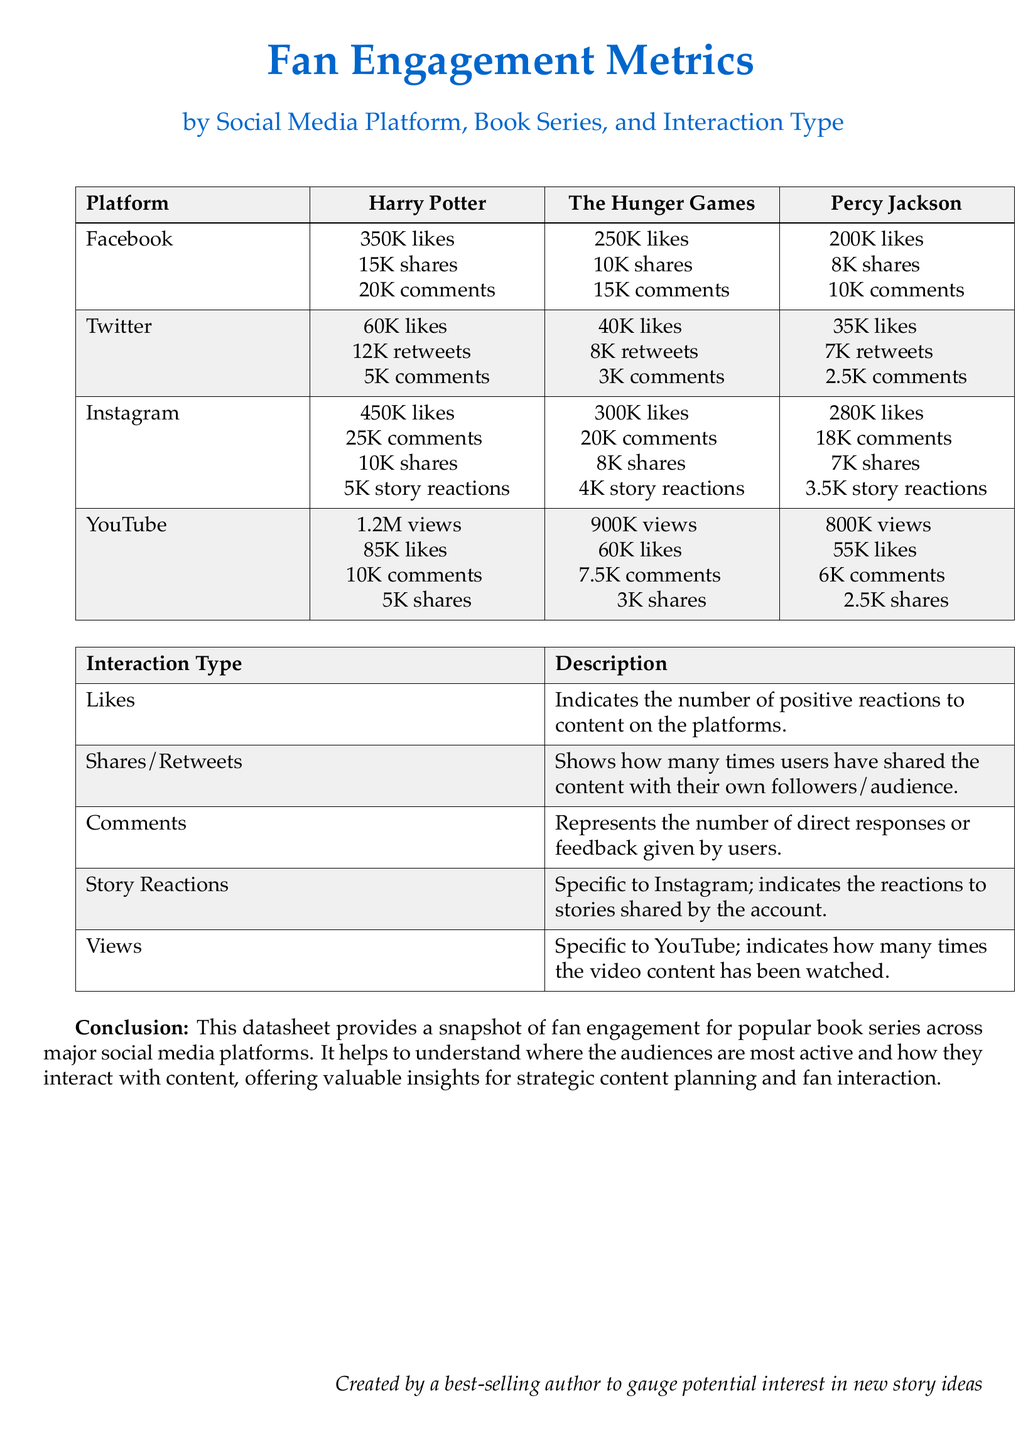What is the number of likes for Harry Potter on Facebook? The likes for Harry Potter on Facebook are listed directly in the document.
Answer: 350K likes How many comments does The Hunger Games have on Instagram? The comments for The Hunger Games on Instagram are explicitly mentioned in the document.
Answer: 20K comments What is the total number of views for Percy Jackson on YouTube? The views for Percy Jackson on YouTube can be found in the corresponding cell of the table.
Answer: 800K views Which book series has the highest number of likes on Instagram? To determine this, we compare the likes of all book series on Instagram provided in the document.
Answer: Harry Potter How many shares does The Hunger Games receive on Facebook? The shares for The Hunger Games on Facebook can be seen in the data table, summing up this specific interaction type.
Answer: 10K shares What is the definition of "Story Reactions"? The definition is provided in the Interaction Type section of the document.
Answer: Specific to Instagram; indicates the reactions to stories shared by the account Which platform shows the highest engagement metrics for Harry Potter? By analyzing the values in the table, we identify which platform has the highest metrics for Harry Potter.
Answer: YouTube How many retweets does Percy Jackson have on Twitter? The number of retweets for Percy Jackson is specifically mentioned in the document.
Answer: 7K retweets 